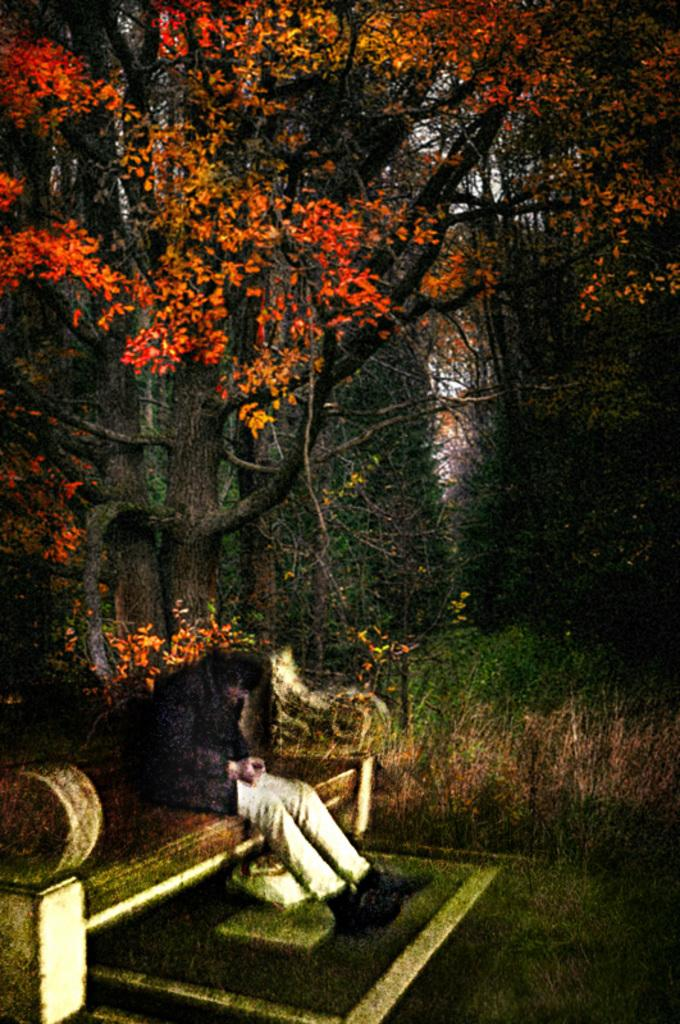What is the main subject of the image? The image contains an art piece. What is located at the bottom of the art piece? There is a bench at the bottom of the art. Is there anyone sitting on the bench? Yes, a person is sitting on the bench. What can be seen in the middle of the art piece? There are trees, plants, and land visible in the middle of the art. What type of science experiment is being conducted on the throne in the image? There is no throne or science experiment present in the image; it features an art piece with a bench and a person sitting on it. 